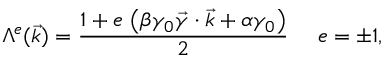Convert formula to latex. <formula><loc_0><loc_0><loc_500><loc_500>\Lambda ^ { e } ( \vec { k } ) = \frac { 1 + e \, \left ( \beta \gamma _ { 0 } \vec { \gamma } \cdot { \vec { k } } + \alpha \gamma _ { 0 } \right ) } { 2 } e = \pm 1 ,</formula> 